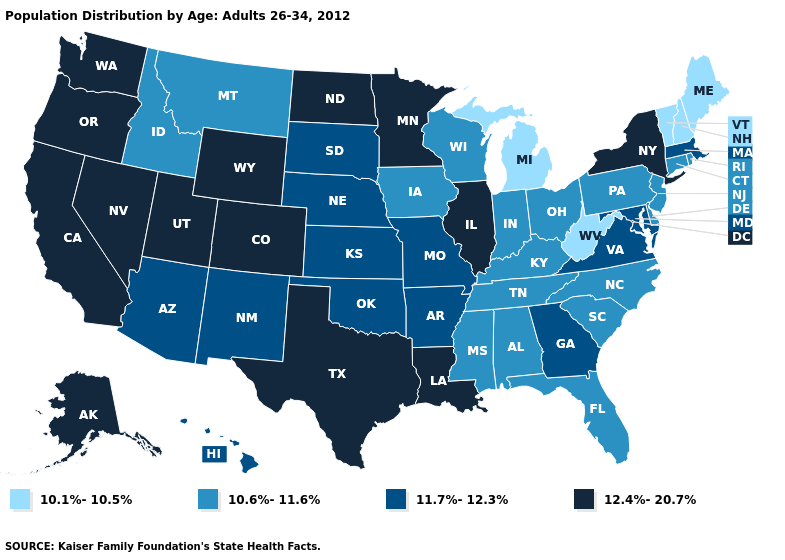Among the states that border North Carolina , does Tennessee have the lowest value?
Give a very brief answer. Yes. What is the value of Massachusetts?
Concise answer only. 11.7%-12.3%. Name the states that have a value in the range 12.4%-20.7%?
Be succinct. Alaska, California, Colorado, Illinois, Louisiana, Minnesota, Nevada, New York, North Dakota, Oregon, Texas, Utah, Washington, Wyoming. Name the states that have a value in the range 10.6%-11.6%?
Write a very short answer. Alabama, Connecticut, Delaware, Florida, Idaho, Indiana, Iowa, Kentucky, Mississippi, Montana, New Jersey, North Carolina, Ohio, Pennsylvania, Rhode Island, South Carolina, Tennessee, Wisconsin. How many symbols are there in the legend?
Write a very short answer. 4. Among the states that border Iowa , which have the highest value?
Quick response, please. Illinois, Minnesota. Name the states that have a value in the range 10.1%-10.5%?
Write a very short answer. Maine, Michigan, New Hampshire, Vermont, West Virginia. What is the highest value in the USA?
Keep it brief. 12.4%-20.7%. Name the states that have a value in the range 10.6%-11.6%?
Short answer required. Alabama, Connecticut, Delaware, Florida, Idaho, Indiana, Iowa, Kentucky, Mississippi, Montana, New Jersey, North Carolina, Ohio, Pennsylvania, Rhode Island, South Carolina, Tennessee, Wisconsin. What is the value of Massachusetts?
Write a very short answer. 11.7%-12.3%. Name the states that have a value in the range 10.6%-11.6%?
Short answer required. Alabama, Connecticut, Delaware, Florida, Idaho, Indiana, Iowa, Kentucky, Mississippi, Montana, New Jersey, North Carolina, Ohio, Pennsylvania, Rhode Island, South Carolina, Tennessee, Wisconsin. Name the states that have a value in the range 11.7%-12.3%?
Give a very brief answer. Arizona, Arkansas, Georgia, Hawaii, Kansas, Maryland, Massachusetts, Missouri, Nebraska, New Mexico, Oklahoma, South Dakota, Virginia. Name the states that have a value in the range 10.6%-11.6%?
Give a very brief answer. Alabama, Connecticut, Delaware, Florida, Idaho, Indiana, Iowa, Kentucky, Mississippi, Montana, New Jersey, North Carolina, Ohio, Pennsylvania, Rhode Island, South Carolina, Tennessee, Wisconsin. Does California have the same value as Indiana?
Concise answer only. No. Which states have the highest value in the USA?
Quick response, please. Alaska, California, Colorado, Illinois, Louisiana, Minnesota, Nevada, New York, North Dakota, Oregon, Texas, Utah, Washington, Wyoming. 